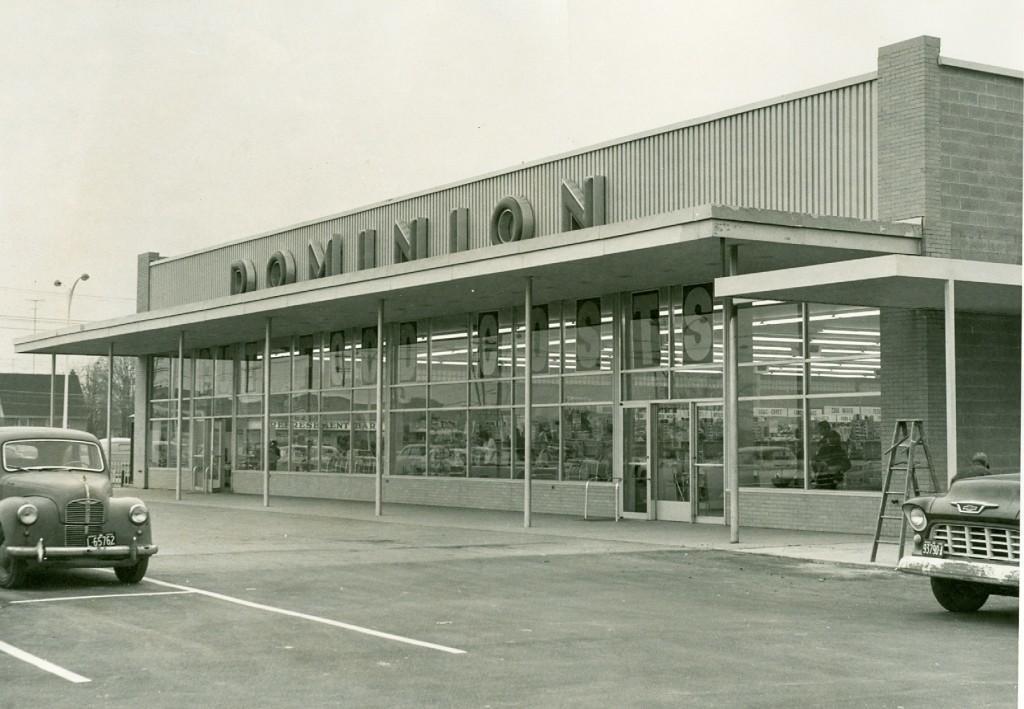Describe this image in one or two sentences. In this image we can see one building with poles, one house, some text on the building, some trees, two cars on the road, two lights with pole, one man near the car, one ladder, some objects on the ground and at the top there is the sky. In the building glass we can see some objects and two persons. 